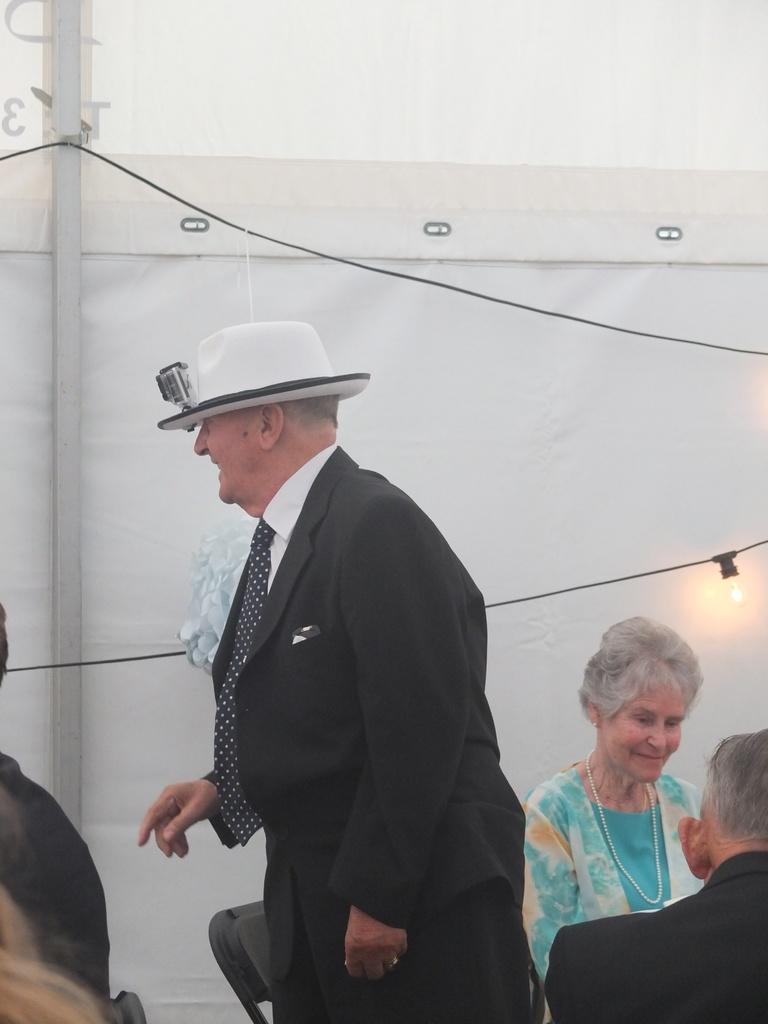Please provide a concise description of this image. In this image we can see people, light and in the background, we can see the white curtain. 